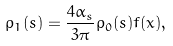Convert formula to latex. <formula><loc_0><loc_0><loc_500><loc_500>\rho _ { 1 } ( s ) = \frac { 4 \alpha _ { s } } { 3 \pi } \rho _ { 0 } ( s ) f ( x ) , \\</formula> 